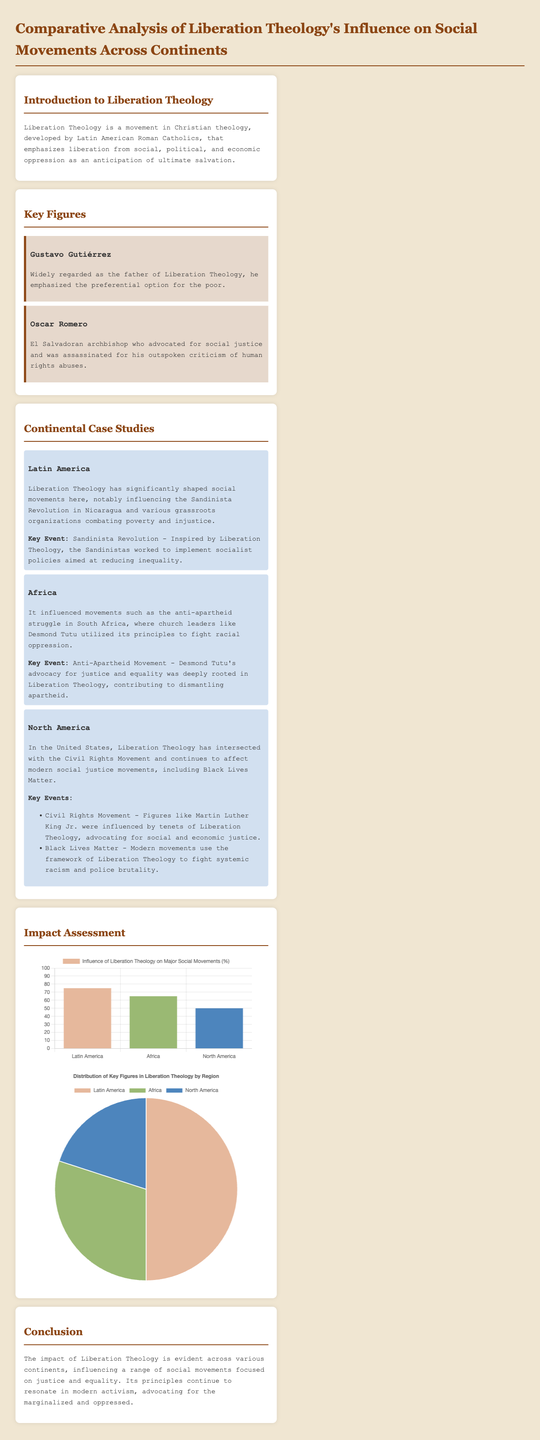What is the primary focus of Liberation Theology? The primary focus of Liberation Theology is on liberation from social, political, and economic oppression.
Answer: liberation from oppression Who is regarded as the father of Liberation Theology? Gustavo Gutiérrez is widely regarded as the father of Liberation Theology.
Answer: Gustavo Gutiérrez Which movement in Latin America was influenced by Liberation Theology? The Sandinista Revolution in Nicaragua was notably influenced by Liberation Theology.
Answer: Sandinista Revolution What percentage of influence does Liberation Theology have on social movements in Africa? The document states that Liberation Theology influences 65% of social movements in Africa.
Answer: 65% In North America, which modern movement continues to be affected by the principles of Liberation Theology? The Black Lives Matter movement is affected by the principles of Liberation Theology.
Answer: Black Lives Matter What was Desmond Tutu's role in the anti-apartheid movement? Desmond Tutu utilized principles of Liberation Theology to fight racial oppression in the anti-apartheid movement.
Answer: Advocate for justice What percentage of key figures in Liberation Theology come from Latin America? The distribution of key figures shows that 50% are from Latin America.
Answer: 50% Which region has the lowest influence of Liberation Theology on major social movements? North America has the lowest influence of Liberation Theology on major social movements at 50%.
Answer: North America What is the color representing Latin America's influence in the bar chart? The color representing Latin America's influence in the bar chart is light brown.
Answer: light brown 